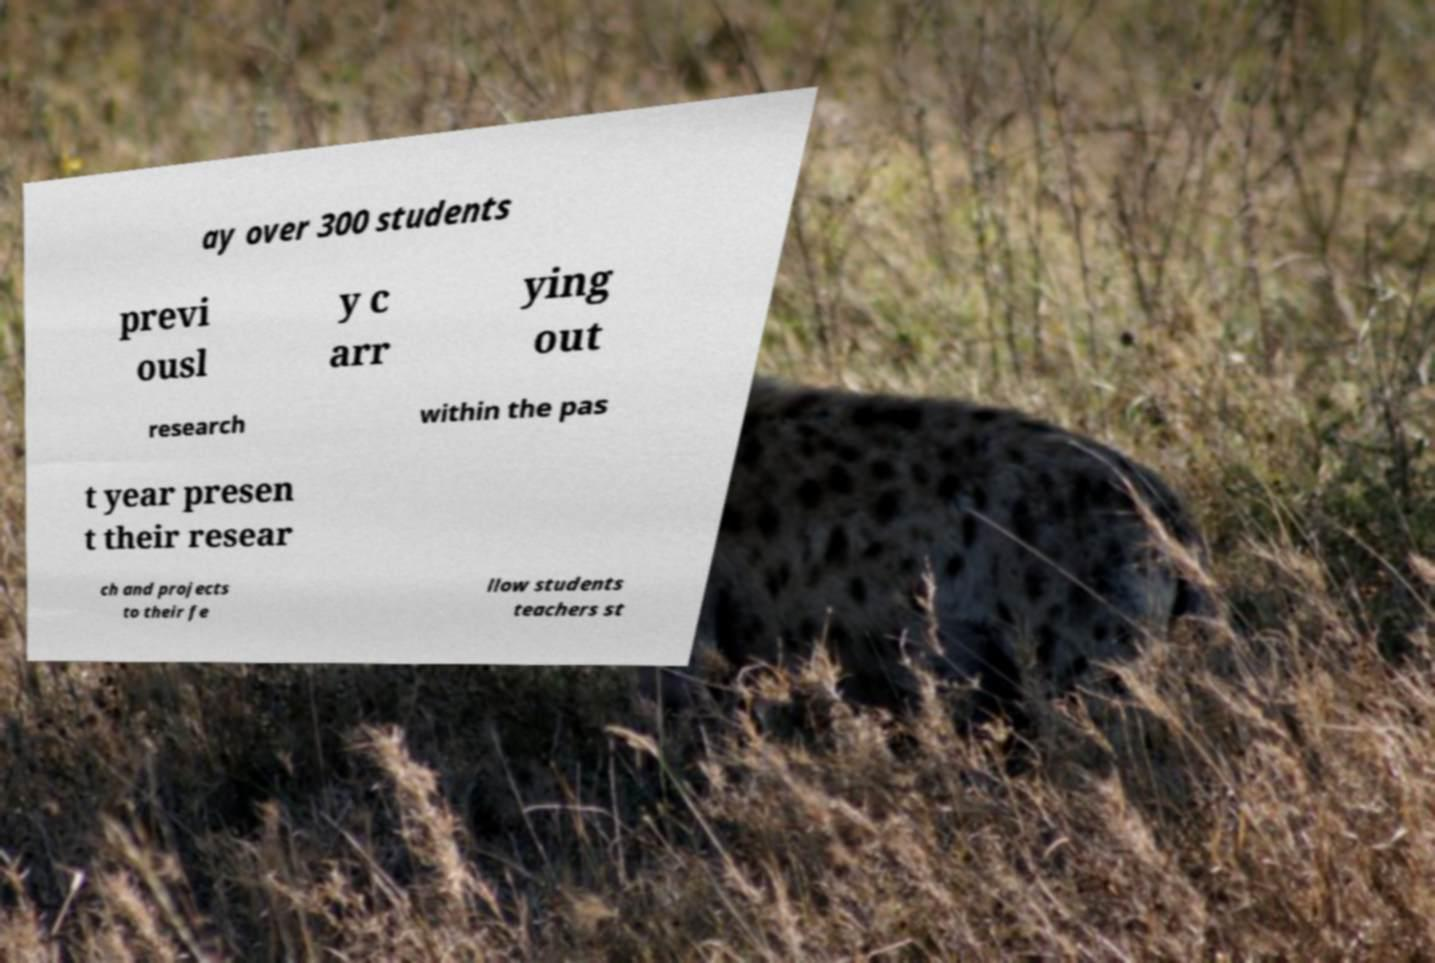Please identify and transcribe the text found in this image. ay over 300 students previ ousl y c arr ying out research within the pas t year presen t their resear ch and projects to their fe llow students teachers st 